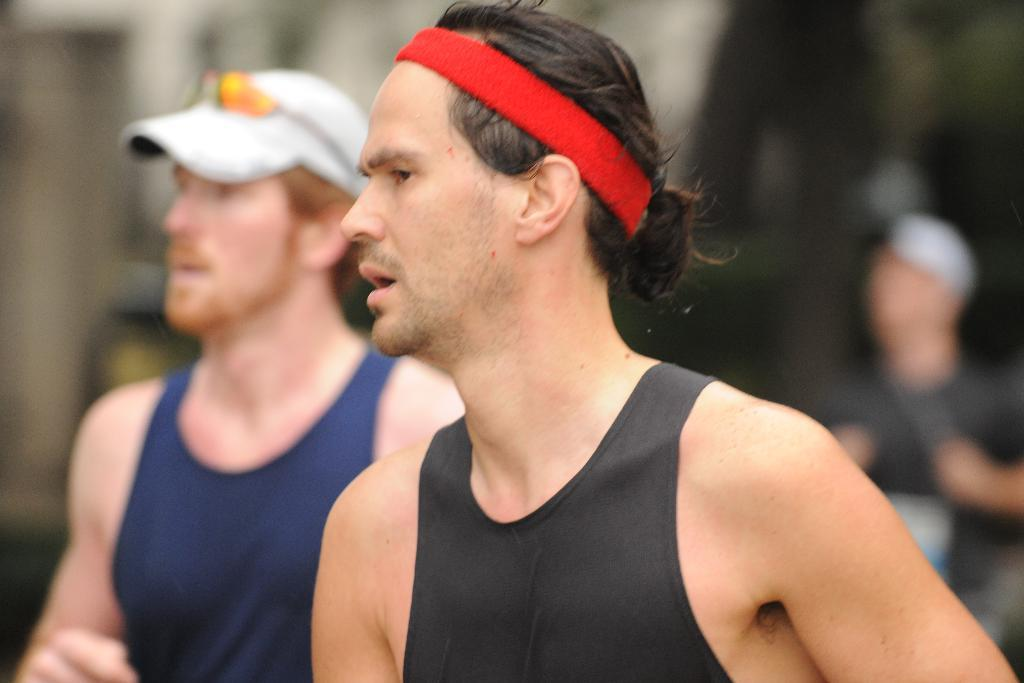Who can be seen in the image? There are people in the image. Can you describe the position of one of the individuals? A man is standing on the left side of the image. What is the man wearing on his head? The man is wearing a cap. What type of flight is the man planning to take in the image? There is no indication of a flight or any travel plans in the image. 